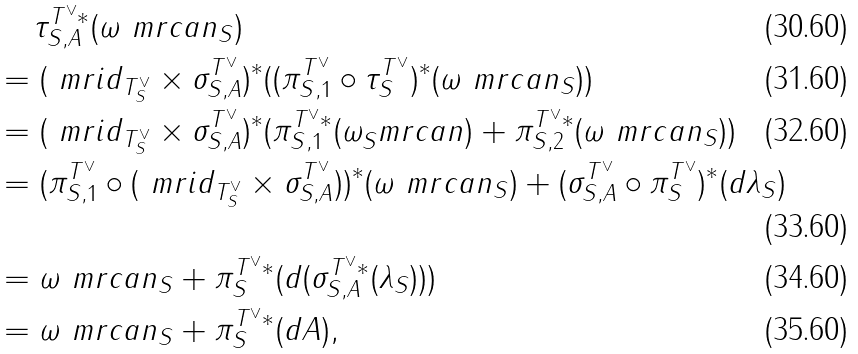Convert formula to latex. <formula><loc_0><loc_0><loc_500><loc_500>& \quad \, \tau ^ { T ^ { \vee } * } _ { S , A } ( \omega ^ { \ } m r { c a n } _ { S } ) \\ & = ( \ m r { i d } _ { T ^ { \vee } _ { S } } \times \sigma _ { S , A } ^ { T ^ { \vee } } ) ^ { * } ( ( \pi _ { S , 1 } ^ { T ^ { \vee } } \circ \tau _ { S } ^ { T ^ { \vee } } ) ^ { * } ( \omega ^ { \ } m r { c a n } _ { S } ) ) \\ & = ( \ m r { i d } _ { T ^ { \vee } _ { S } } \times \sigma _ { S , A } ^ { T ^ { \vee } } ) ^ { * } ( \pi _ { S , 1 } ^ { T ^ { \vee } * } ( \omega _ { S } ^ { \ } m r { c a n } ) + \pi ^ { T ^ { \vee } * } _ { S , 2 } ( \omega ^ { \ } m r { c a n } _ { S } ) ) \\ & = ( \pi _ { S , 1 } ^ { T ^ { \vee } } \circ ( \ m r { i d } _ { T ^ { \vee } _ { S } } \times \sigma _ { S , A } ^ { T ^ { \vee } } ) ) ^ { * } ( \omega ^ { \ } m r { c a n } _ { S } ) + ( \sigma _ { S , A } ^ { T ^ { \vee } } \circ \pi ^ { T ^ { \vee } } _ { S } ) ^ { * } ( d \lambda _ { S } ) \\ & = \omega ^ { \ } m r { c a n } _ { S } + \pi ^ { T ^ { \vee } * } _ { S } ( d ( \sigma ^ { T ^ { \vee } * } _ { S , A } ( \lambda _ { S } ) ) ) \\ & = \omega ^ { \ } m r { c a n } _ { S } + \pi _ { S } ^ { T ^ { \vee } * } ( d A ) ,</formula> 